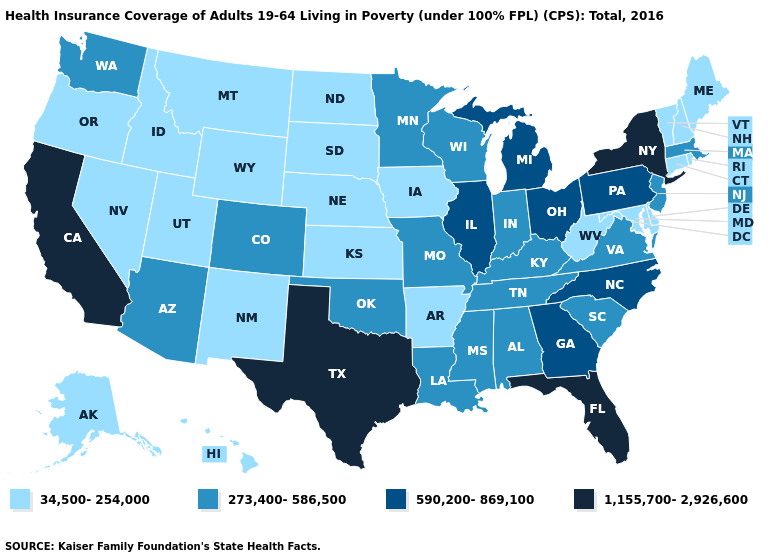What is the value of Indiana?
Short answer required. 273,400-586,500. Name the states that have a value in the range 1,155,700-2,926,600?
Give a very brief answer. California, Florida, New York, Texas. Among the states that border North Carolina , does South Carolina have the lowest value?
Be succinct. Yes. Does Alaska have the lowest value in the USA?
Be succinct. Yes. Name the states that have a value in the range 1,155,700-2,926,600?
Write a very short answer. California, Florida, New York, Texas. Does Kansas have the highest value in the USA?
Give a very brief answer. No. Does Iowa have the highest value in the MidWest?
Give a very brief answer. No. What is the highest value in the South ?
Concise answer only. 1,155,700-2,926,600. Does the map have missing data?
Answer briefly. No. Which states have the lowest value in the Northeast?
Answer briefly. Connecticut, Maine, New Hampshire, Rhode Island, Vermont. Does Texas have the highest value in the South?
Concise answer only. Yes. Does the first symbol in the legend represent the smallest category?
Concise answer only. Yes. Among the states that border New Hampshire , which have the lowest value?
Quick response, please. Maine, Vermont. What is the value of New Hampshire?
Write a very short answer. 34,500-254,000. Name the states that have a value in the range 1,155,700-2,926,600?
Short answer required. California, Florida, New York, Texas. 